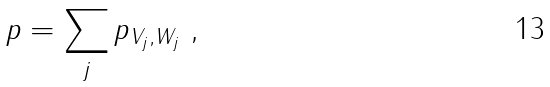<formula> <loc_0><loc_0><loc_500><loc_500>p = \sum _ { j } p _ { V _ { j } , W _ { j } } \ ,</formula> 